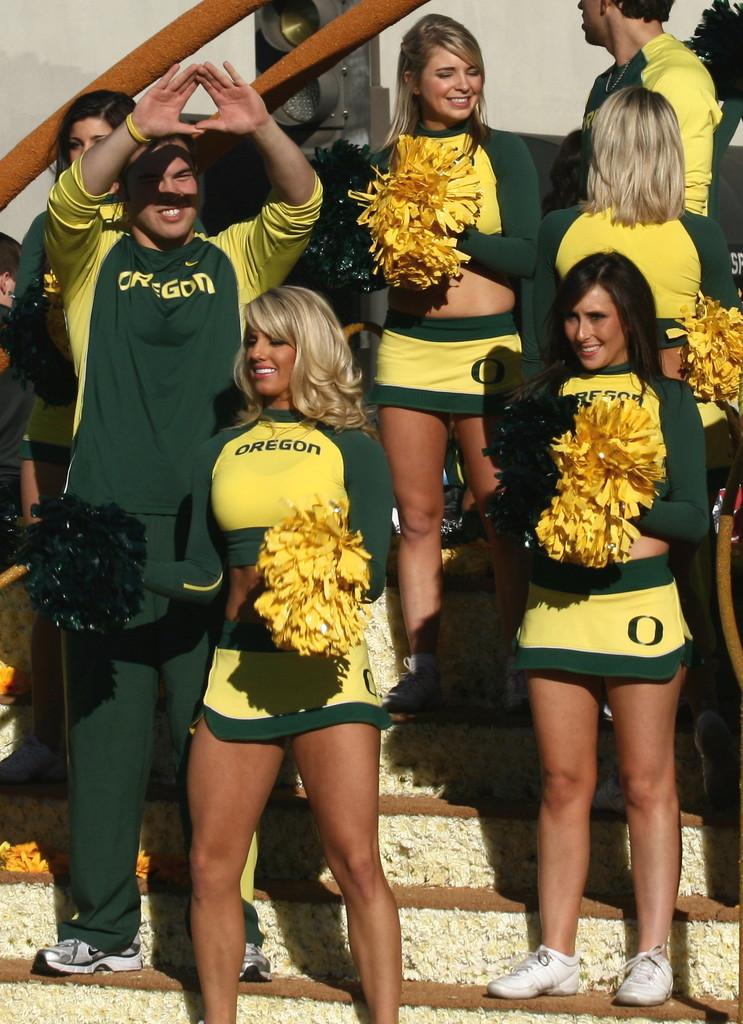What state are the cheerleaders cheering for?
Your response must be concise. Oregon. 